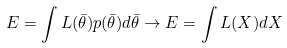Convert formula to latex. <formula><loc_0><loc_0><loc_500><loc_500>E = \int L ( \bar { \theta } ) p ( \bar { \theta } ) d \bar { \theta } \rightarrow E = \int L ( X ) d X</formula> 